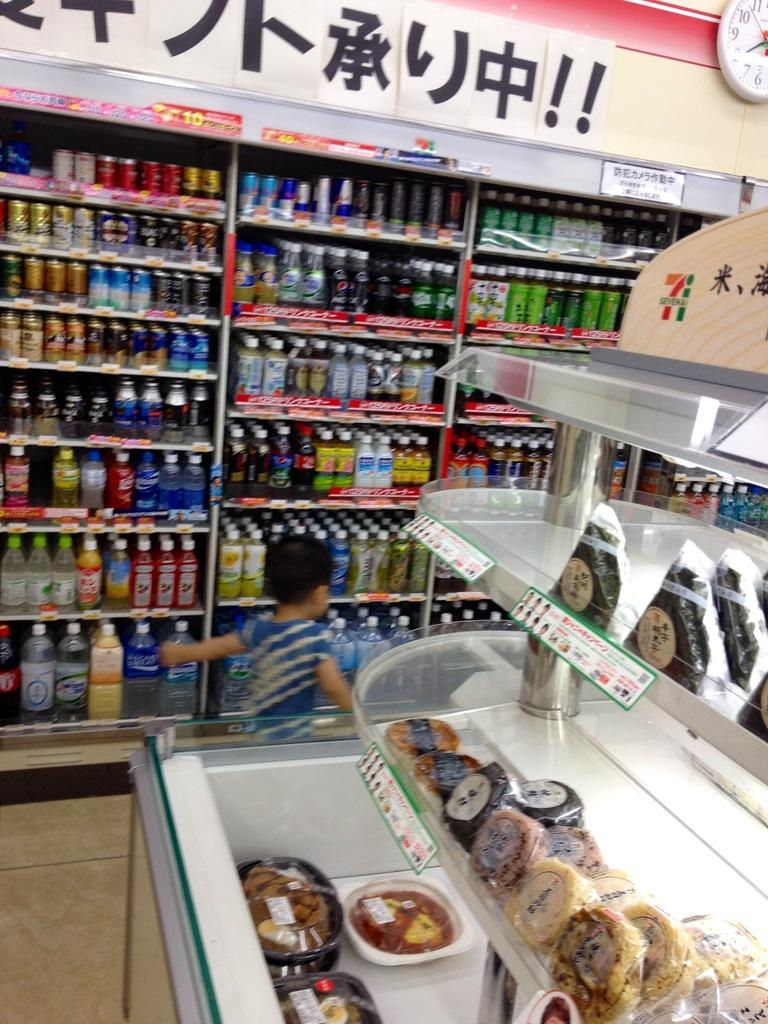<image>
Render a clear and concise summary of the photo. A child in a convience store and a clock on a wall showing the time of 8. 